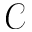<formula> <loc_0><loc_0><loc_500><loc_500>\mathcal { C }</formula> 